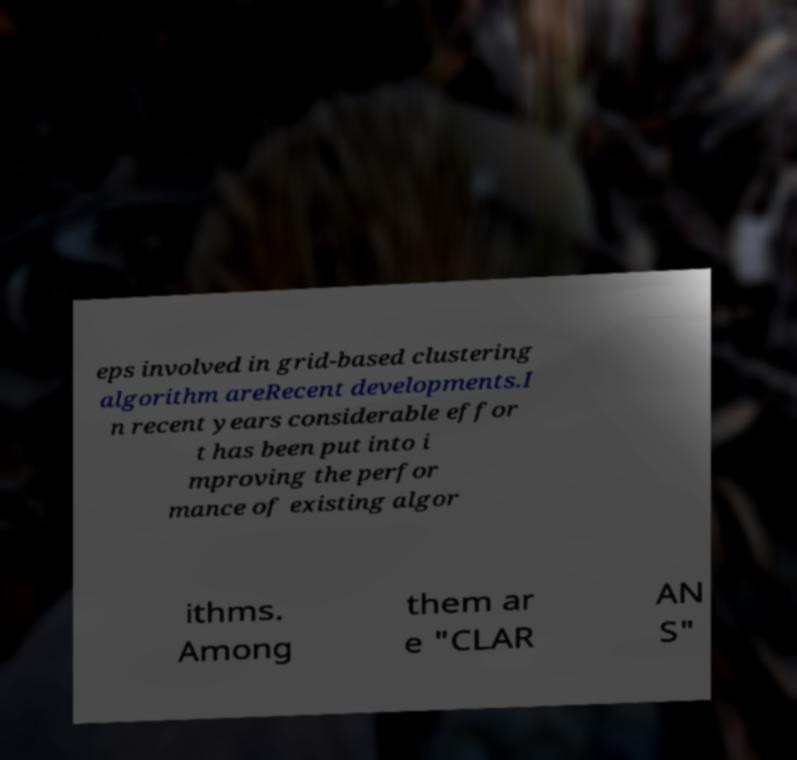Please read and relay the text visible in this image. What does it say? eps involved in grid-based clustering algorithm areRecent developments.I n recent years considerable effor t has been put into i mproving the perfor mance of existing algor ithms. Among them ar e "CLAR AN S" 